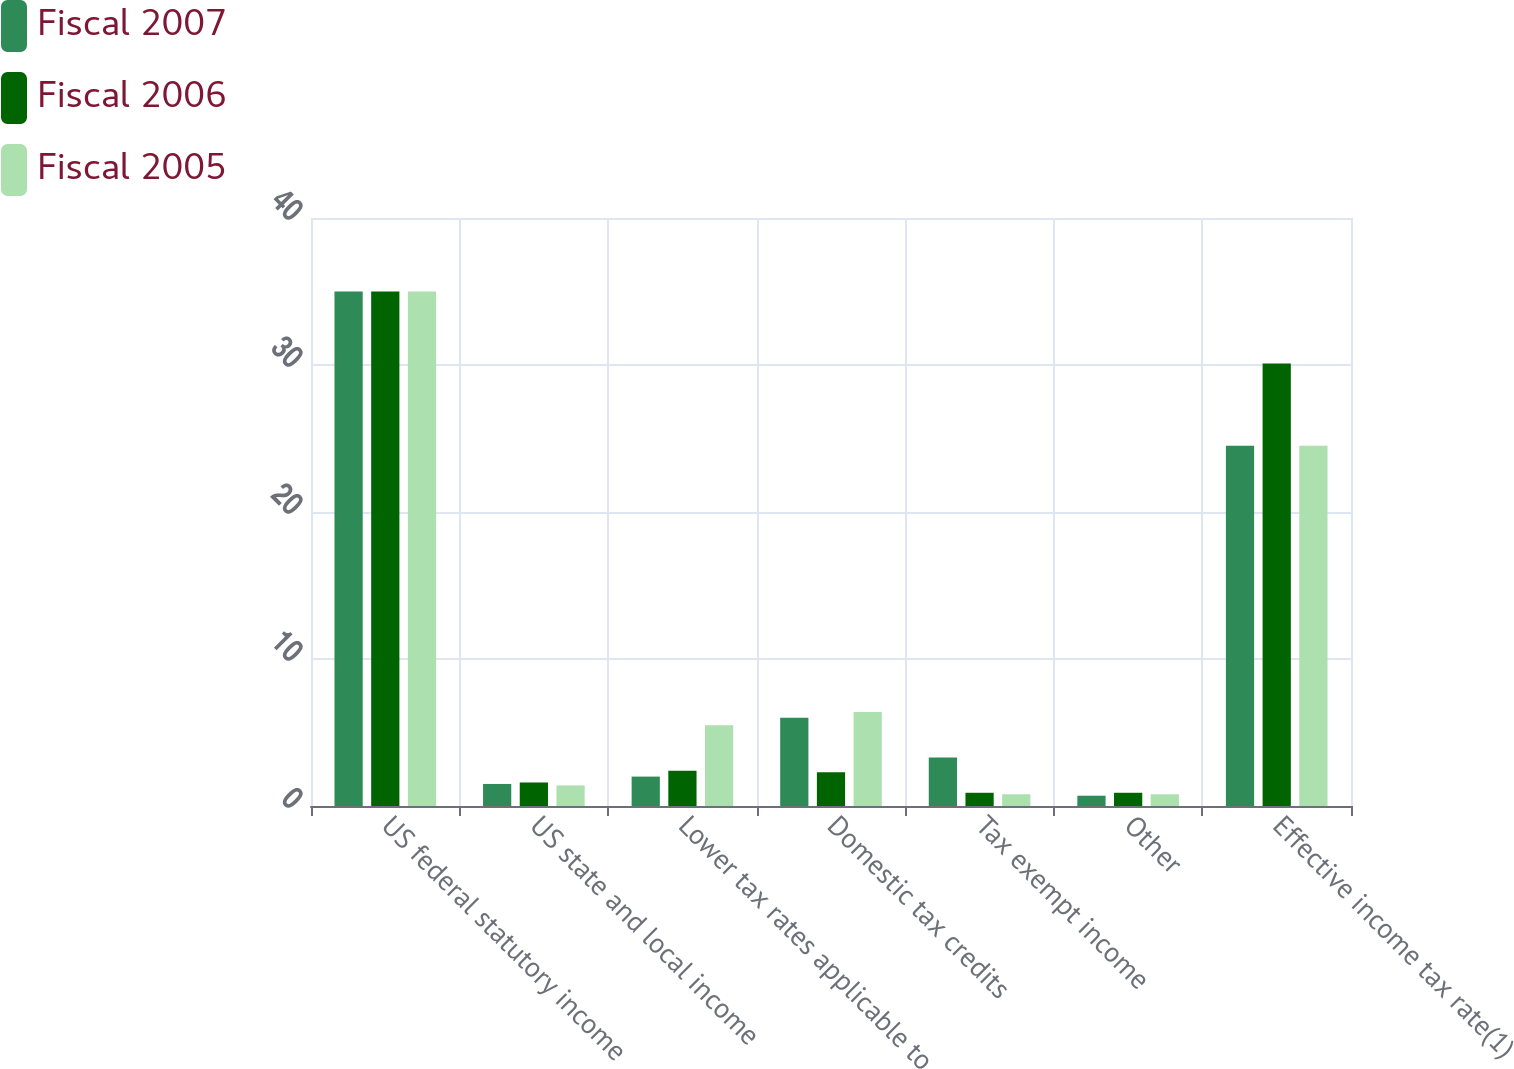Convert chart to OTSL. <chart><loc_0><loc_0><loc_500><loc_500><stacked_bar_chart><ecel><fcel>US federal statutory income<fcel>US state and local income<fcel>Lower tax rates applicable to<fcel>Domestic tax credits<fcel>Tax exempt income<fcel>Other<fcel>Effective income tax rate(1)<nl><fcel>Fiscal 2007<fcel>35<fcel>1.5<fcel>2<fcel>6<fcel>3.3<fcel>0.7<fcel>24.5<nl><fcel>Fiscal 2006<fcel>35<fcel>1.6<fcel>2.4<fcel>2.3<fcel>0.9<fcel>0.9<fcel>30.1<nl><fcel>Fiscal 2005<fcel>35<fcel>1.4<fcel>5.5<fcel>6.4<fcel>0.8<fcel>0.8<fcel>24.5<nl></chart> 